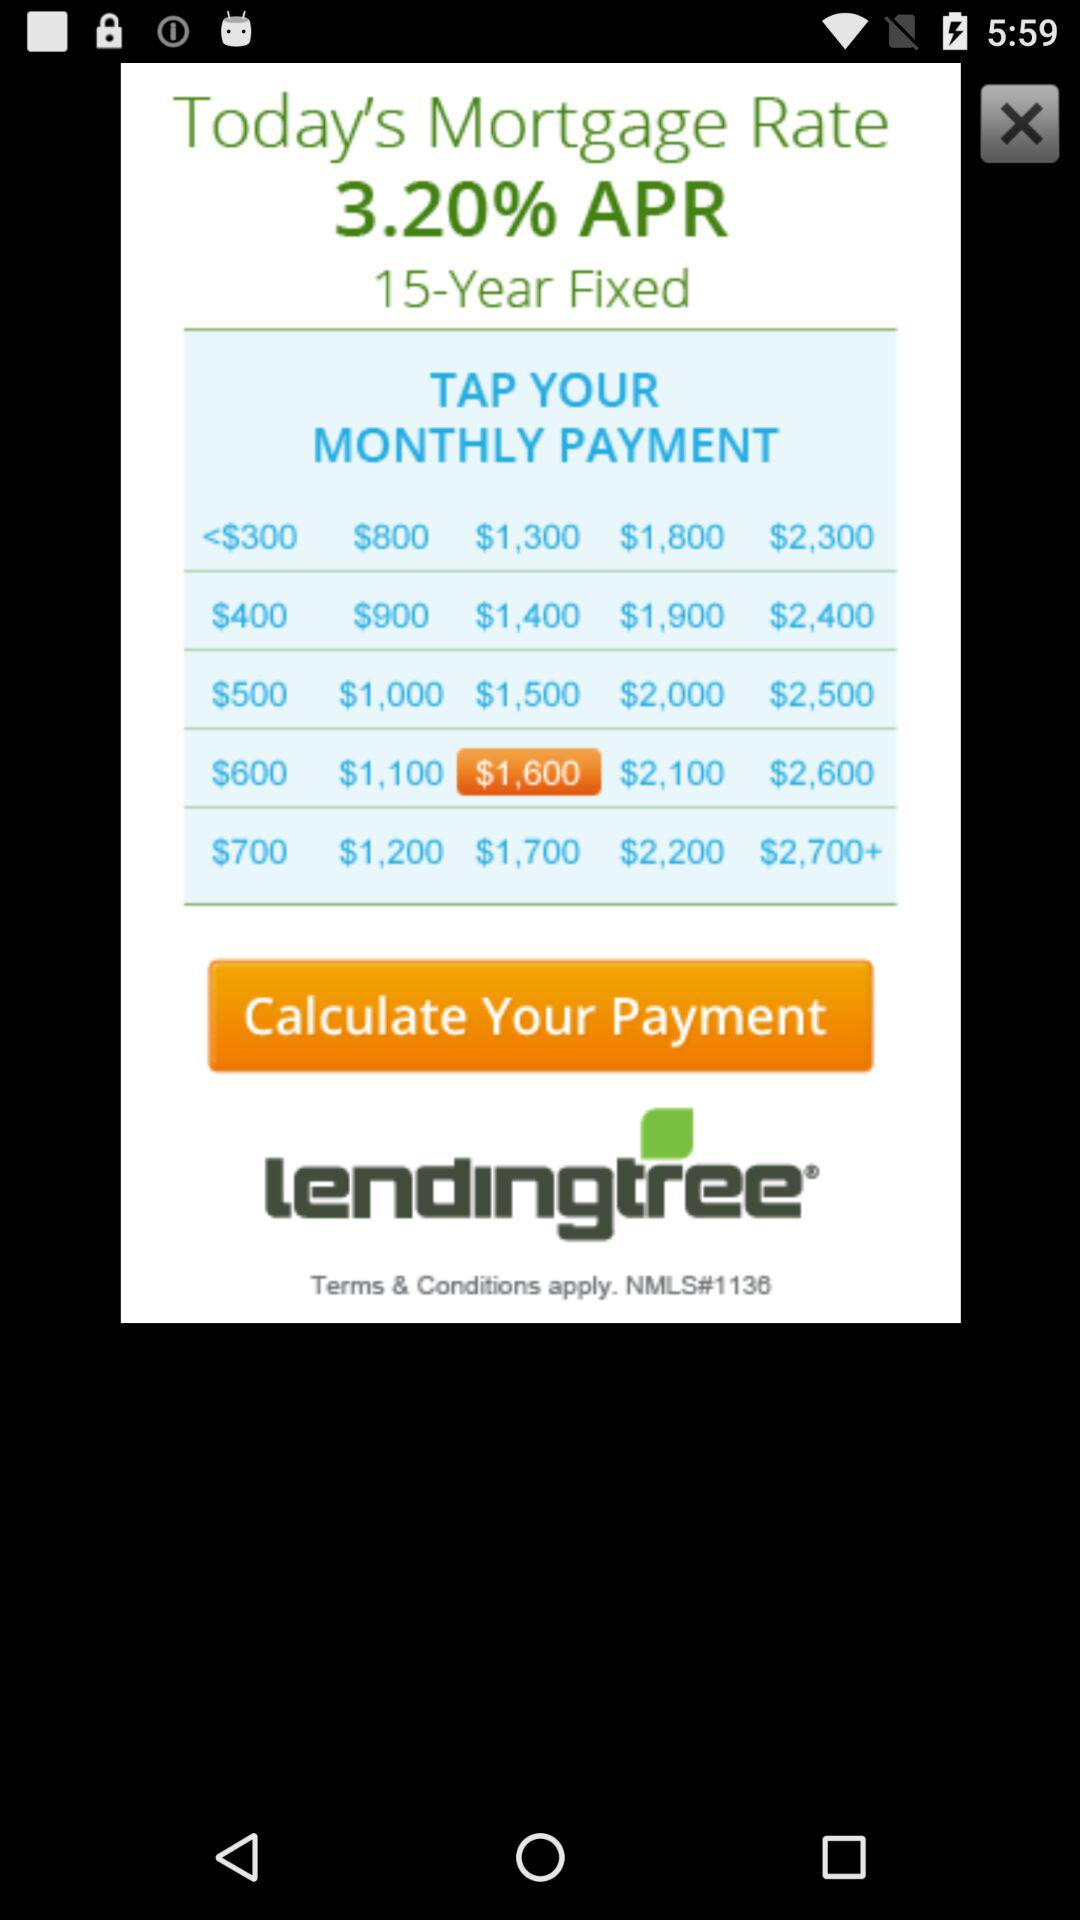What is the application name? The application name is "lendingtree". 